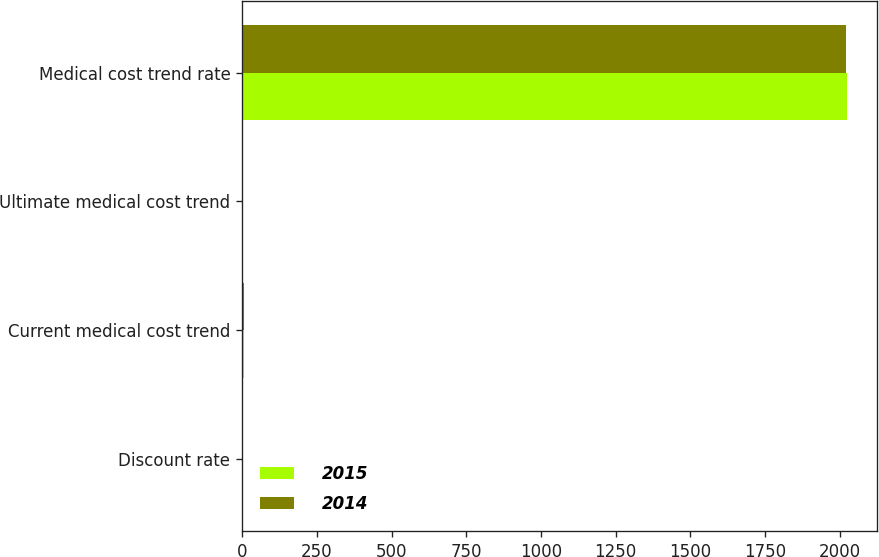Convert chart to OTSL. <chart><loc_0><loc_0><loc_500><loc_500><stacked_bar_chart><ecel><fcel>Discount rate<fcel>Current medical cost trend<fcel>Ultimate medical cost trend<fcel>Medical cost trend rate<nl><fcel>2015<fcel>3.9<fcel>5.8<fcel>4.75<fcel>2023<nl><fcel>2014<fcel>4.8<fcel>6.5<fcel>4.75<fcel>2021<nl></chart> 